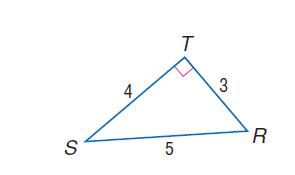Answer the mathemtical geometry problem and directly provide the correct option letter.
Question: find \sin R.
Choices: A: 0.2 B: 0.4 C: 0.6 D: 0.8 D 